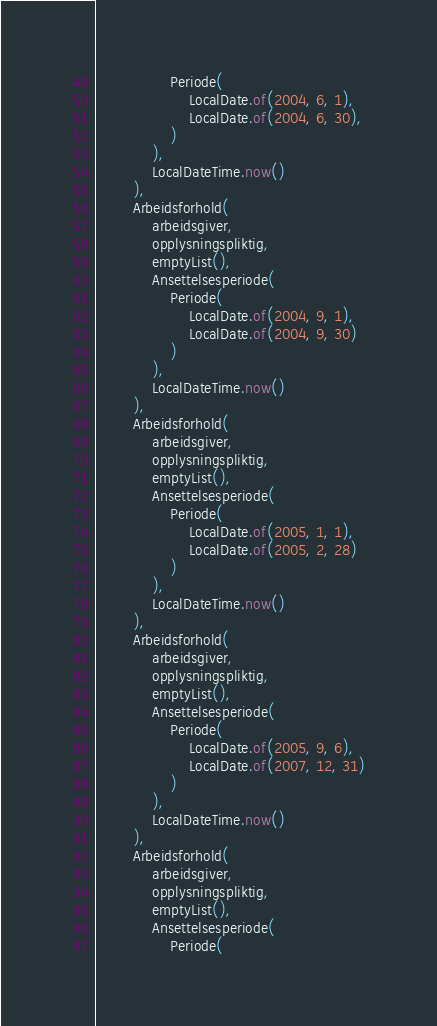Convert code to text. <code><loc_0><loc_0><loc_500><loc_500><_Kotlin_>                Periode(
                    LocalDate.of(2004, 6, 1),
                    LocalDate.of(2004, 6, 30),
                )
            ),
            LocalDateTime.now()
        ),
        Arbeidsforhold(
            arbeidsgiver,
            opplysningspliktig,
            emptyList(),
            Ansettelsesperiode(
                Periode(
                    LocalDate.of(2004, 9, 1),
                    LocalDate.of(2004, 9, 30)
                )
            ),
            LocalDateTime.now()
        ),
        Arbeidsforhold(
            arbeidsgiver,
            opplysningspliktig,
            emptyList(),
            Ansettelsesperiode(
                Periode(
                    LocalDate.of(2005, 1, 1),
                    LocalDate.of(2005, 2, 28)
                )
            ),
            LocalDateTime.now()
        ),
        Arbeidsforhold(
            arbeidsgiver,
            opplysningspliktig,
            emptyList(),
            Ansettelsesperiode(
                Periode(
                    LocalDate.of(2005, 9, 6),
                    LocalDate.of(2007, 12, 31)
                )
            ),
            LocalDateTime.now()
        ),
        Arbeidsforhold(
            arbeidsgiver,
            opplysningspliktig,
            emptyList(),
            Ansettelsesperiode(
                Periode(</code> 